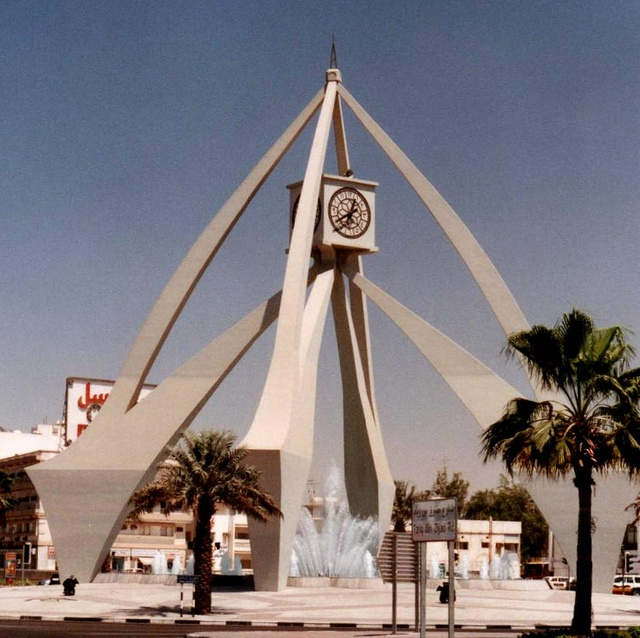Describe the objects in this image and their specific colors. I can see clock in blue, tan, lightgray, maroon, and gray tones, car in blue, black, lightgray, gray, and maroon tones, people in blue, black, maroon, gray, and tan tones, car in blue, tan, maroon, and gray tones, and clock in black, maroon, and blue tones in this image. 